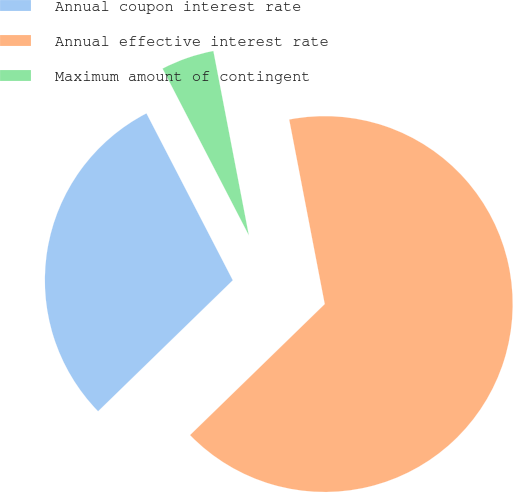Convert chart to OTSL. <chart><loc_0><loc_0><loc_500><loc_500><pie_chart><fcel>Annual coupon interest rate<fcel>Annual effective interest rate<fcel>Maximum amount of contingent<nl><fcel>29.68%<fcel>65.75%<fcel>4.57%<nl></chart> 